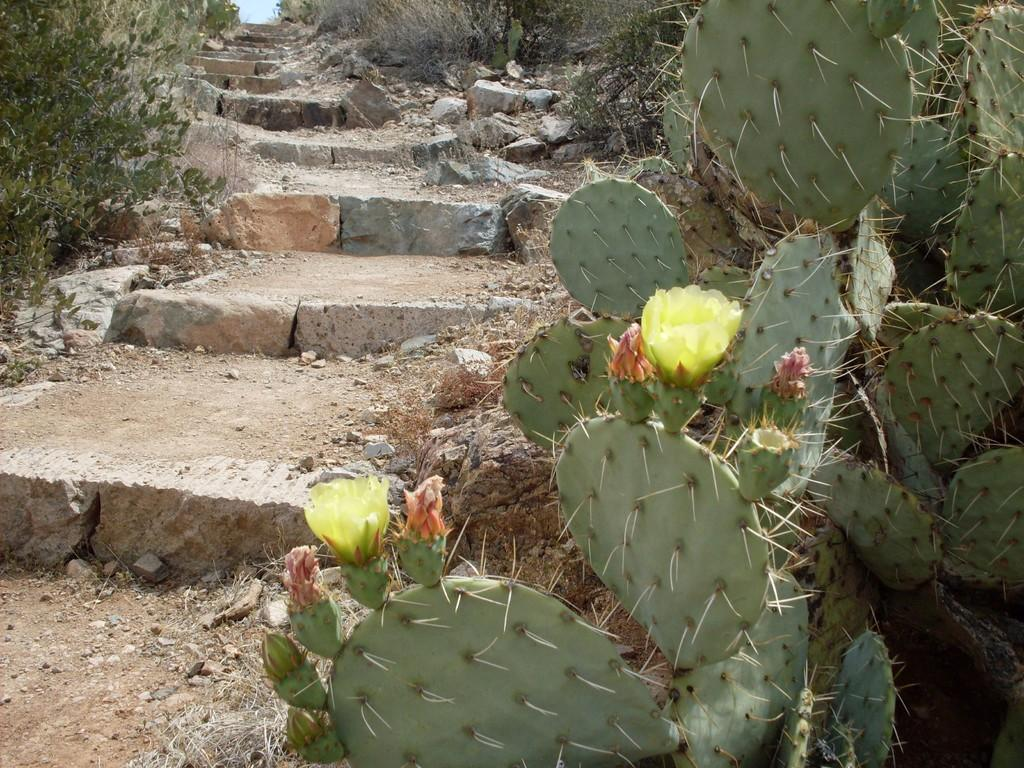What type of natural elements can be seen in the image? There are stones, trees, and plants in the image. What man-made structure is present in the image? There are stairs in the image. Are there any specific types of plants in the image? Yes, there is a cactus in the image. What type of mark can be seen on the partner's forehead in the image? There is no partner or mark present in the image. What is the head doing in the image? There is no head visible in the image. 